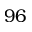<formula> <loc_0><loc_0><loc_500><loc_500>9 6</formula> 